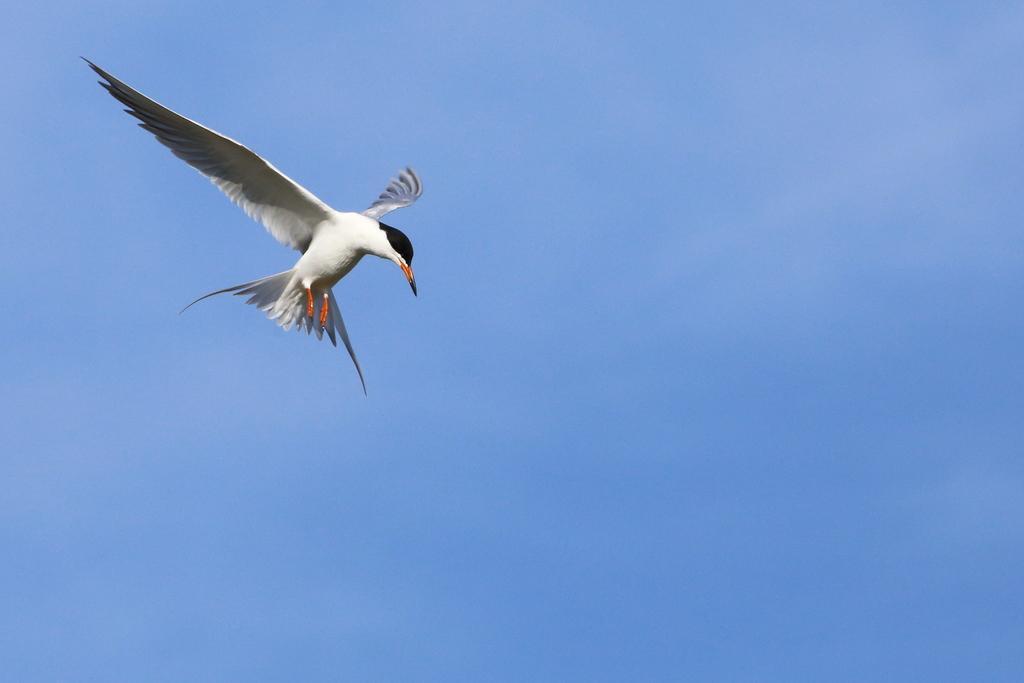Describe this image in one or two sentences. In this image I can see a white color bird is flying in the air. In the background, I can see the sky in blue color. 